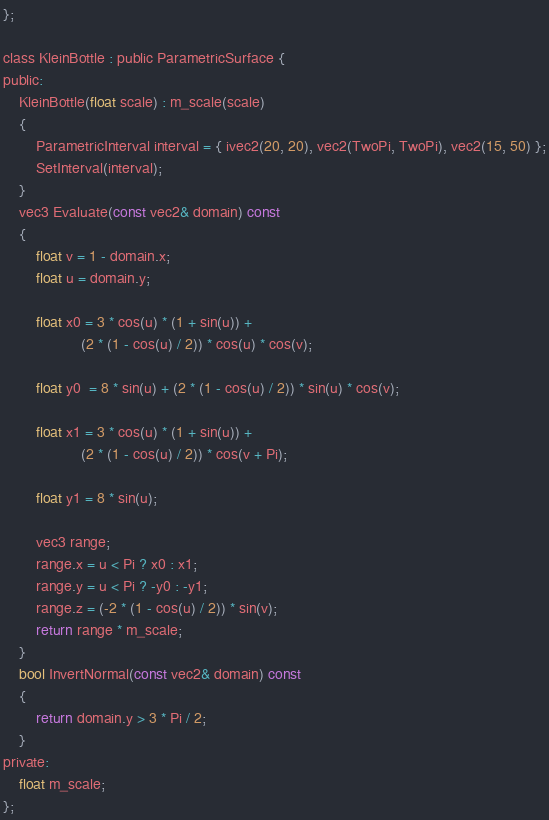<code> <loc_0><loc_0><loc_500><loc_500><_C_>};

class KleinBottle : public ParametricSurface {
public:
    KleinBottle(float scale) : m_scale(scale)
    {
        ParametricInterval interval = { ivec2(20, 20), vec2(TwoPi, TwoPi), vec2(15, 50) };
        SetInterval(interval);
    }
    vec3 Evaluate(const vec2& domain) const
    {
        float v = 1 - domain.x;
        float u = domain.y;
        
        float x0 = 3 * cos(u) * (1 + sin(u)) +
                   (2 * (1 - cos(u) / 2)) * cos(u) * cos(v);
        
        float y0  = 8 * sin(u) + (2 * (1 - cos(u) / 2)) * sin(u) * cos(v);
        
        float x1 = 3 * cos(u) * (1 + sin(u)) +
                   (2 * (1 - cos(u) / 2)) * cos(v + Pi);
        
        float y1 = 8 * sin(u);
        
        vec3 range;
        range.x = u < Pi ? x0 : x1;
        range.y = u < Pi ? -y0 : -y1;
        range.z = (-2 * (1 - cos(u) / 2)) * sin(v);
        return range * m_scale;
    }
    bool InvertNormal(const vec2& domain) const
    {
        return domain.y > 3 * Pi / 2;
    }
private:
    float m_scale;
};
</code> 